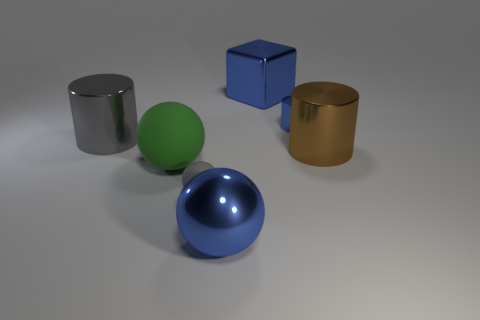What number of other objects are there of the same color as the large shiny sphere?
Ensure brevity in your answer.  2. What number of matte things are tiny gray cylinders or green spheres?
Offer a very short reply. 1. The thing that is on the left side of the tiny blue metallic thing and right of the big blue sphere is what color?
Keep it short and to the point. Blue. There is a cylinder right of the blue shiny cylinder; is its size the same as the large gray shiny thing?
Your answer should be compact. Yes. What number of objects are big objects that are on the right side of the blue block or blue blocks?
Offer a very short reply. 2. Is there a purple metallic object that has the same size as the green thing?
Your answer should be compact. No. What material is the sphere that is the same size as the blue cylinder?
Give a very brief answer. Rubber. The thing that is both to the right of the gray matte object and in front of the big matte thing has what shape?
Your answer should be very brief. Sphere. What is the color of the big cylinder right of the metallic ball?
Ensure brevity in your answer.  Brown. There is a shiny cylinder that is both behind the big brown metallic cylinder and right of the small gray rubber ball; what size is it?
Offer a very short reply. Small. 